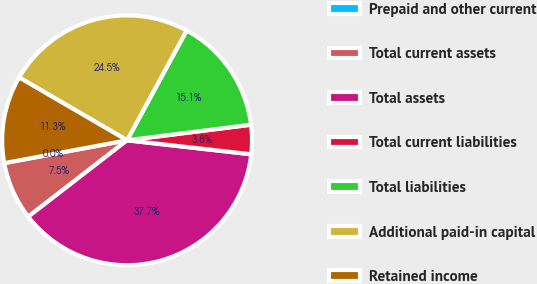<chart> <loc_0><loc_0><loc_500><loc_500><pie_chart><fcel>Prepaid and other current<fcel>Total current assets<fcel>Total assets<fcel>Total current liabilities<fcel>Total liabilities<fcel>Additional paid-in capital<fcel>Retained income<nl><fcel>0.0%<fcel>7.55%<fcel>37.74%<fcel>3.78%<fcel>15.1%<fcel>24.52%<fcel>11.32%<nl></chart> 